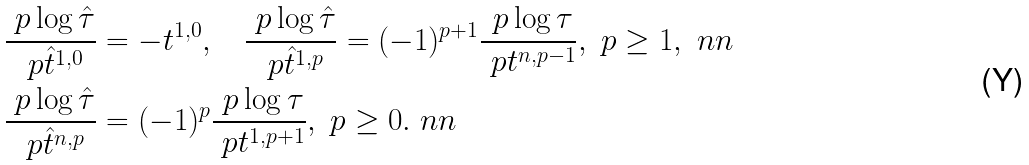<formula> <loc_0><loc_0><loc_500><loc_500>& \frac { \ p \log \hat { \tau } } { \ p \hat { t } ^ { 1 , 0 } } = - t ^ { 1 , 0 } , \quad \frac { \ p \log \hat { \tau } } { \ p \hat { t } ^ { 1 , p } } = ( - 1 ) ^ { p + 1 } \frac { \ p \log \tau } { \ p t ^ { n , p - 1 } } , \ p \geq 1 , \ n n \\ & \frac { \ p \log \hat { \tau } } { \ p \hat { t } ^ { n , p } } = ( - 1 ) ^ { p } \frac { \ p \log \tau } { \ p t ^ { 1 , p + 1 } } , \ p \geq 0 . \ n n</formula> 